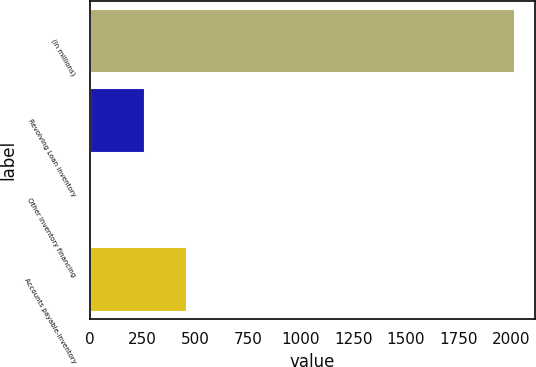Convert chart. <chart><loc_0><loc_0><loc_500><loc_500><bar_chart><fcel>(in millions)<fcel>Revolving Loan inventory<fcel>Other inventory financing<fcel>Accounts payable-inventory<nl><fcel>2013<fcel>256.1<fcel>0.5<fcel>457.35<nl></chart> 